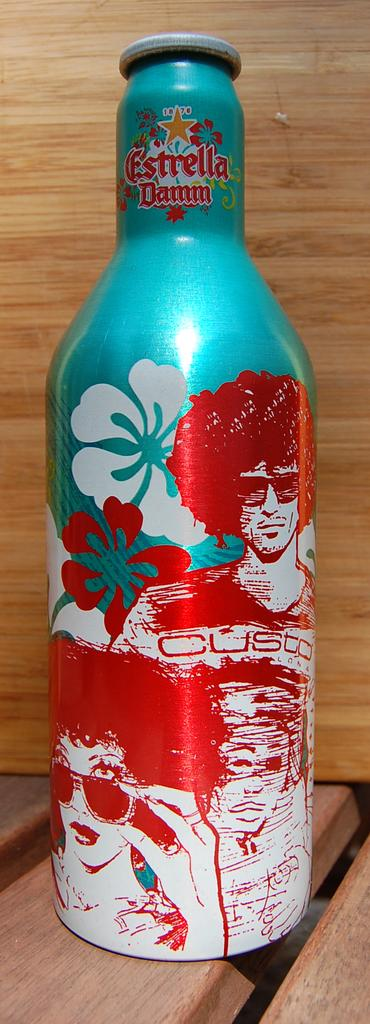<image>
Present a compact description of the photo's key features. Summer Bottle includes the brand Estrella Damm with people on the description. 